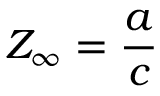Convert formula to latex. <formula><loc_0><loc_0><loc_500><loc_500>Z _ { \infty } = { \frac { a } { c } }</formula> 